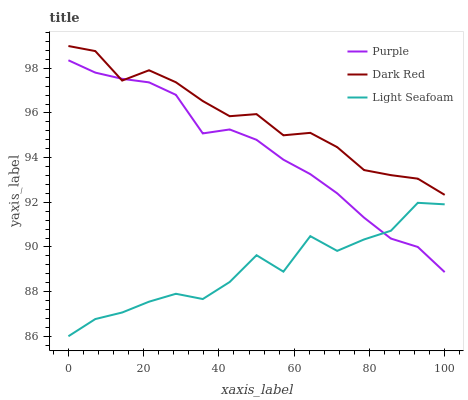Does Dark Red have the minimum area under the curve?
Answer yes or no. No. Does Light Seafoam have the maximum area under the curve?
Answer yes or no. No. Is Dark Red the smoothest?
Answer yes or no. No. Is Dark Red the roughest?
Answer yes or no. No. Does Dark Red have the lowest value?
Answer yes or no. No. Does Light Seafoam have the highest value?
Answer yes or no. No. Is Light Seafoam less than Dark Red?
Answer yes or no. Yes. Is Dark Red greater than Light Seafoam?
Answer yes or no. Yes. Does Light Seafoam intersect Dark Red?
Answer yes or no. No. 